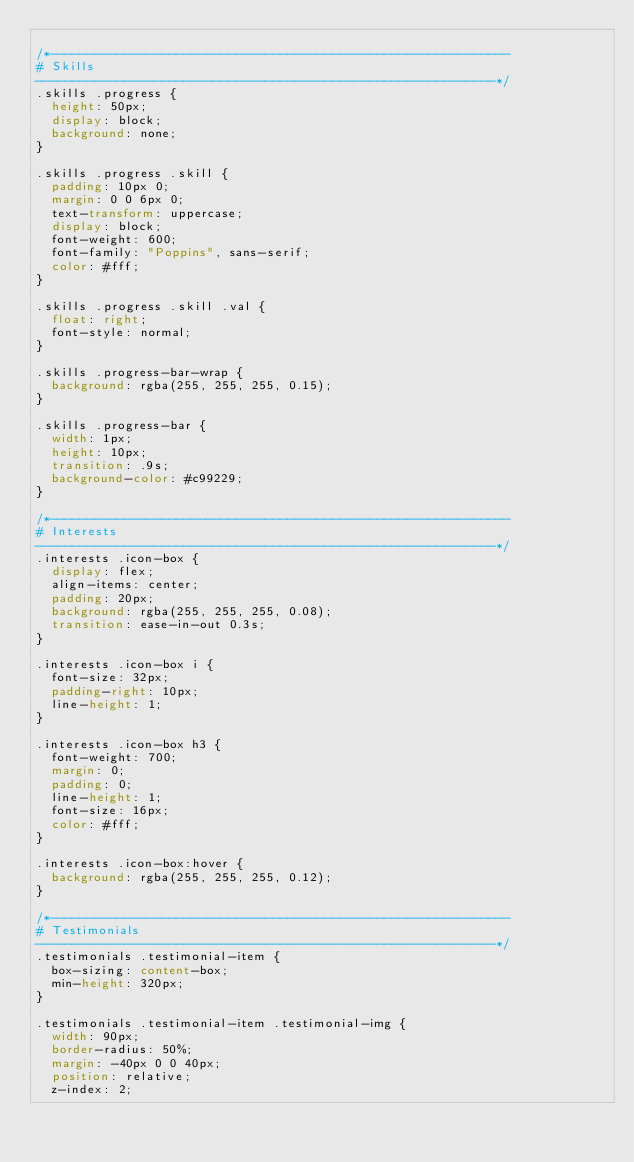<code> <loc_0><loc_0><loc_500><loc_500><_CSS_>
/*--------------------------------------------------------------
# Skills
--------------------------------------------------------------*/
.skills .progress {
  height: 50px;
  display: block;
  background: none;
}

.skills .progress .skill {
  padding: 10px 0;
  margin: 0 0 6px 0;
  text-transform: uppercase;
  display: block;
  font-weight: 600;
  font-family: "Poppins", sans-serif;
  color: #fff;
}

.skills .progress .skill .val {
  float: right;
  font-style: normal;
}

.skills .progress-bar-wrap {
  background: rgba(255, 255, 255, 0.15);
}

.skills .progress-bar {
  width: 1px;
  height: 10px;
  transition: .9s;
  background-color: #c99229;
}

/*--------------------------------------------------------------
# Interests
--------------------------------------------------------------*/
.interests .icon-box {
  display: flex;
  align-items: center;
  padding: 20px;
  background: rgba(255, 255, 255, 0.08);
  transition: ease-in-out 0.3s;
}

.interests .icon-box i {
  font-size: 32px;
  padding-right: 10px;
  line-height: 1;
}

.interests .icon-box h3 {
  font-weight: 700;
  margin: 0;
  padding: 0;
  line-height: 1;
  font-size: 16px;
  color: #fff;
}

.interests .icon-box:hover {
  background: rgba(255, 255, 255, 0.12);
}

/*--------------------------------------------------------------
# Testimonials
--------------------------------------------------------------*/
.testimonials .testimonial-item {
  box-sizing: content-box;
  min-height: 320px;
}

.testimonials .testimonial-item .testimonial-img {
  width: 90px;
  border-radius: 50%;
  margin: -40px 0 0 40px;
  position: relative;
  z-index: 2;</code> 